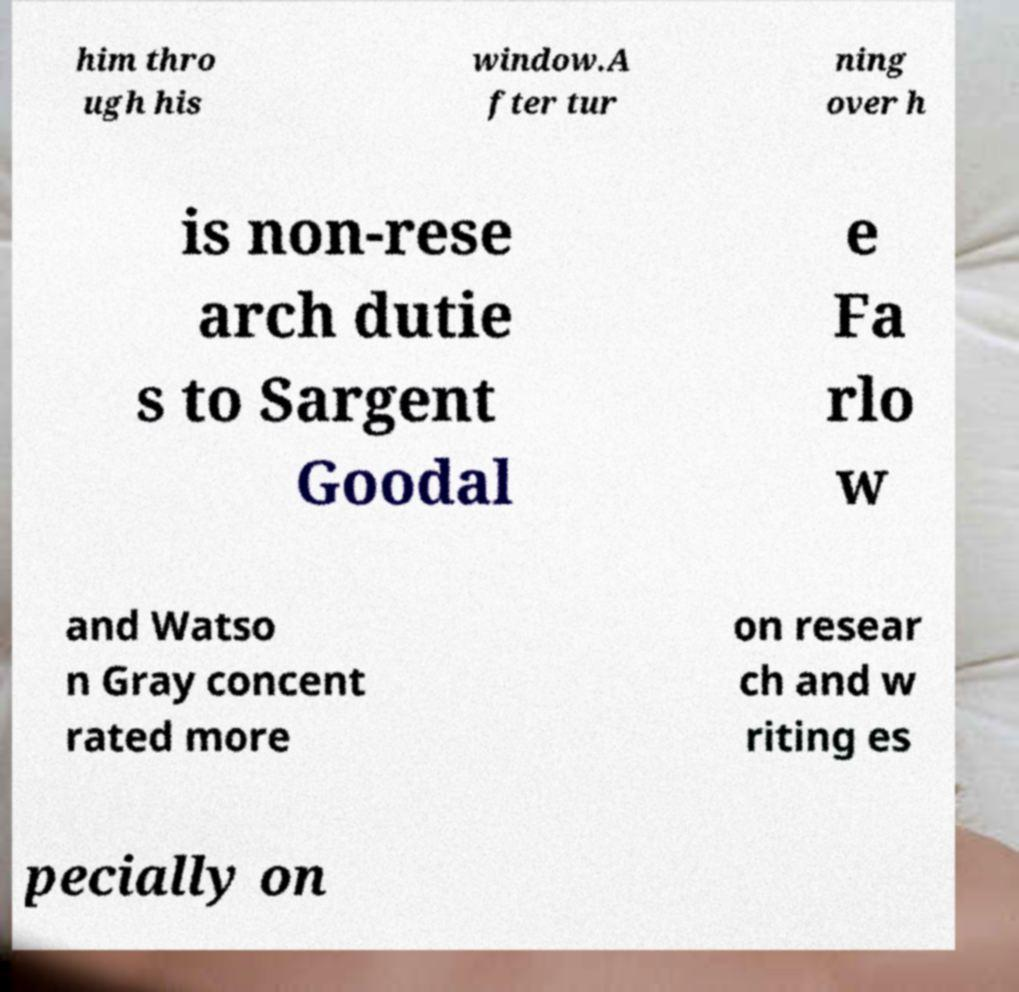There's text embedded in this image that I need extracted. Can you transcribe it verbatim? him thro ugh his window.A fter tur ning over h is non-rese arch dutie s to Sargent Goodal e Fa rlo w and Watso n Gray concent rated more on resear ch and w riting es pecially on 